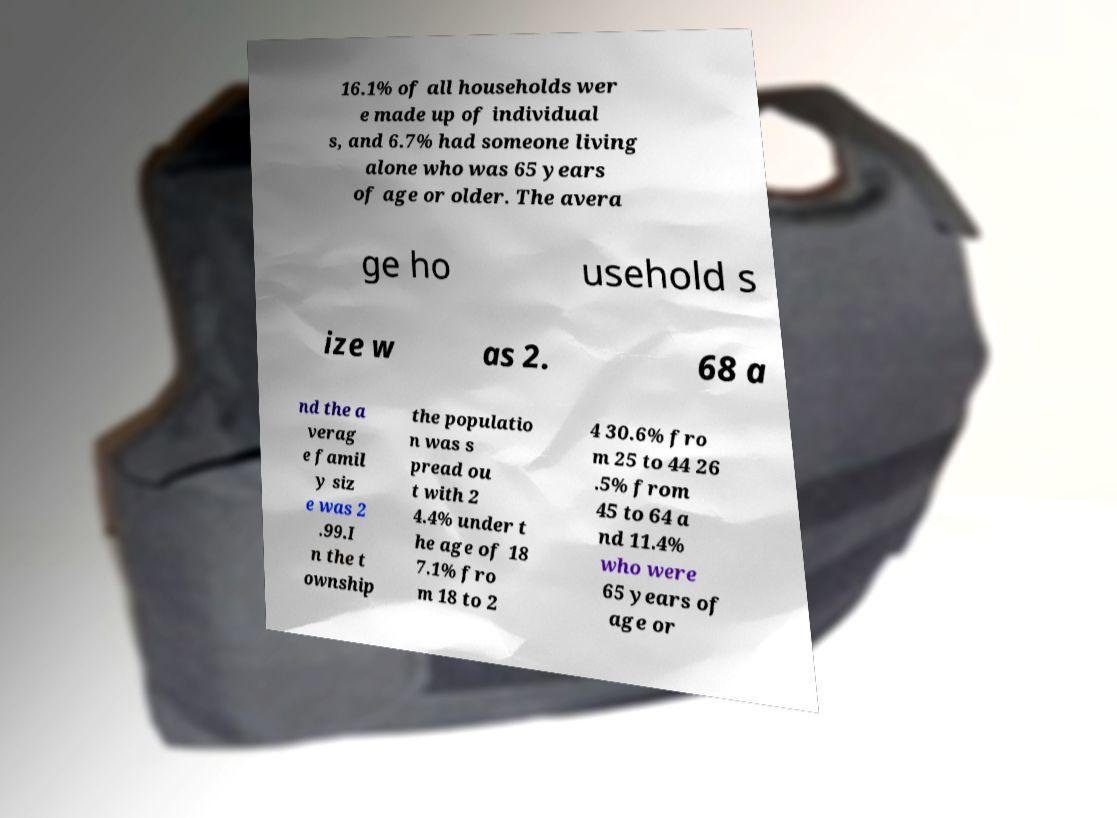Please identify and transcribe the text found in this image. 16.1% of all households wer e made up of individual s, and 6.7% had someone living alone who was 65 years of age or older. The avera ge ho usehold s ize w as 2. 68 a nd the a verag e famil y siz e was 2 .99.I n the t ownship the populatio n was s pread ou t with 2 4.4% under t he age of 18 7.1% fro m 18 to 2 4 30.6% fro m 25 to 44 26 .5% from 45 to 64 a nd 11.4% who were 65 years of age or 